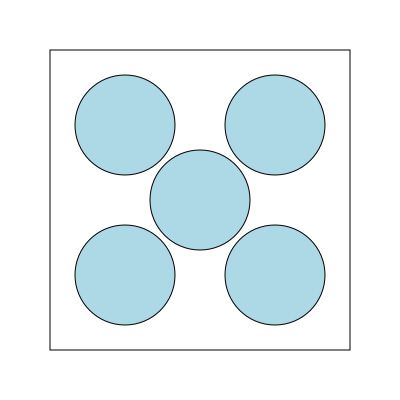Given a square container with side length $L$ and identical circular objects with radius $r$, what is the maximum number of circles that can be packed into the container using the arrangement shown, and what is the packing density $\eta$ (ratio of area occupied by circles to total container area) as a function of $L$ and $r$? To solve this problem, we'll follow these steps:

1) Observe the arrangement: 5 circles are packed in the square container, with 4 in the corners and 1 in the center.

2) For this arrangement to work, the diameter of each circle (2r) must be equal to half the side length of the square:

   $2r = \frac{L}{2}$ or $r = \frac{L}{4}$

3) The maximum number of circles that can be packed in this arrangement is 5.

4) To calculate the packing density $\eta$, we need:
   - Area of the square container: $A_{square} = L^2$
   - Area of each circle: $A_{circle} = \pi r^2$
   - Total area of circles: $A_{total circles} = 5\pi r^2$

5) The packing density is:

   $\eta = \frac{A_{total circles}}{A_{square}} = \frac{5\pi r^2}{L^2}$

6) Substituting $r = \frac{L}{4}$ from step 2:

   $\eta = \frac{5\pi (\frac{L}{4})^2}{L^2} = \frac{5\pi}{16} \approx 0.9817$

Therefore, the maximum number of circles is 5, and the packing density is $\frac{5\pi}{16}$ or approximately 0.9817.
Answer: 5 circles; $\eta = \frac{5\pi}{16} \approx 0.9817$ 